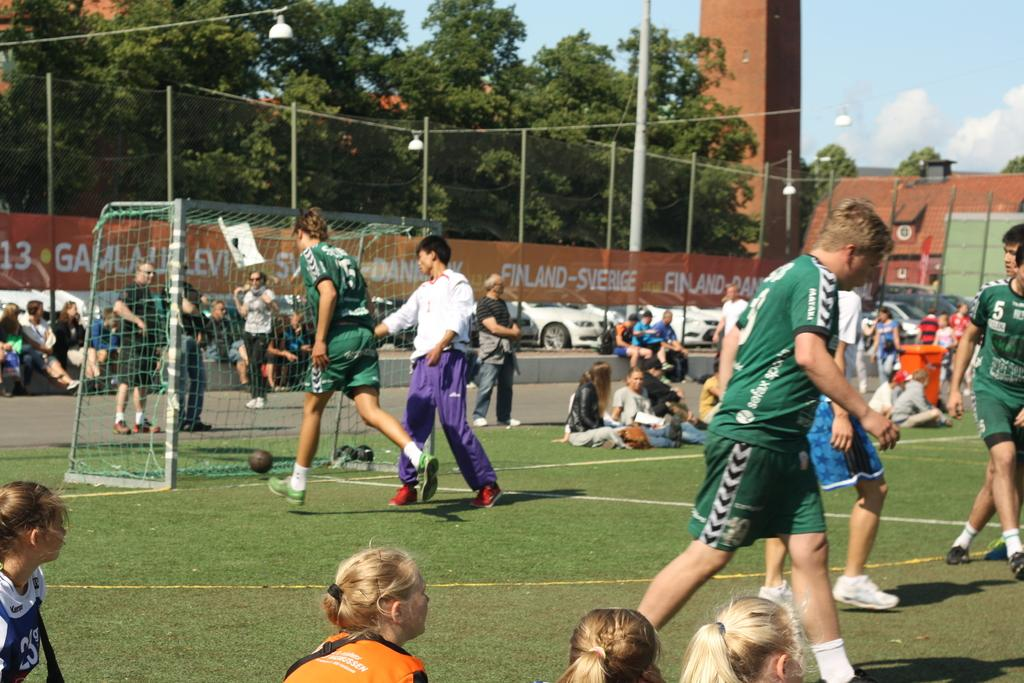<image>
Share a concise interpretation of the image provided. A sports field has an orange banner that says Finland-Sverige. 